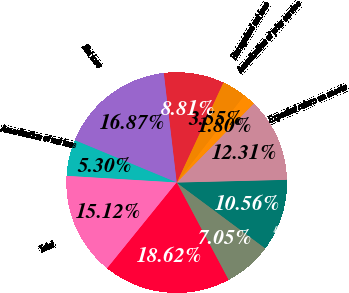Convert chart. <chart><loc_0><loc_0><loc_500><loc_500><pie_chart><fcel>Service cost - benefits earned<fcel>Interest cost on projected<fcel>Expected return on assets<fcel>Amortization of prior service<fcel>Recognized net loss<fcel>Net periodic pension costs<fcel>Net loss<fcel>Amortization of net loss<fcel>Total<fcel>Total recognized as net<nl><fcel>7.05%<fcel>10.56%<fcel>12.31%<fcel>1.8%<fcel>3.55%<fcel>8.81%<fcel>16.87%<fcel>5.3%<fcel>15.12%<fcel>18.62%<nl></chart> 